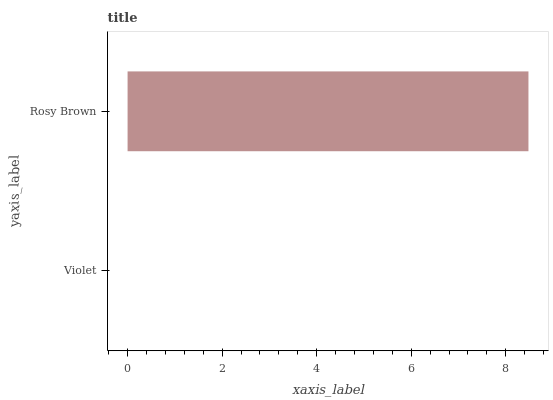Is Violet the minimum?
Answer yes or no. Yes. Is Rosy Brown the maximum?
Answer yes or no. Yes. Is Rosy Brown the minimum?
Answer yes or no. No. Is Rosy Brown greater than Violet?
Answer yes or no. Yes. Is Violet less than Rosy Brown?
Answer yes or no. Yes. Is Violet greater than Rosy Brown?
Answer yes or no. No. Is Rosy Brown less than Violet?
Answer yes or no. No. Is Rosy Brown the high median?
Answer yes or no. Yes. Is Violet the low median?
Answer yes or no. Yes. Is Violet the high median?
Answer yes or no. No. Is Rosy Brown the low median?
Answer yes or no. No. 